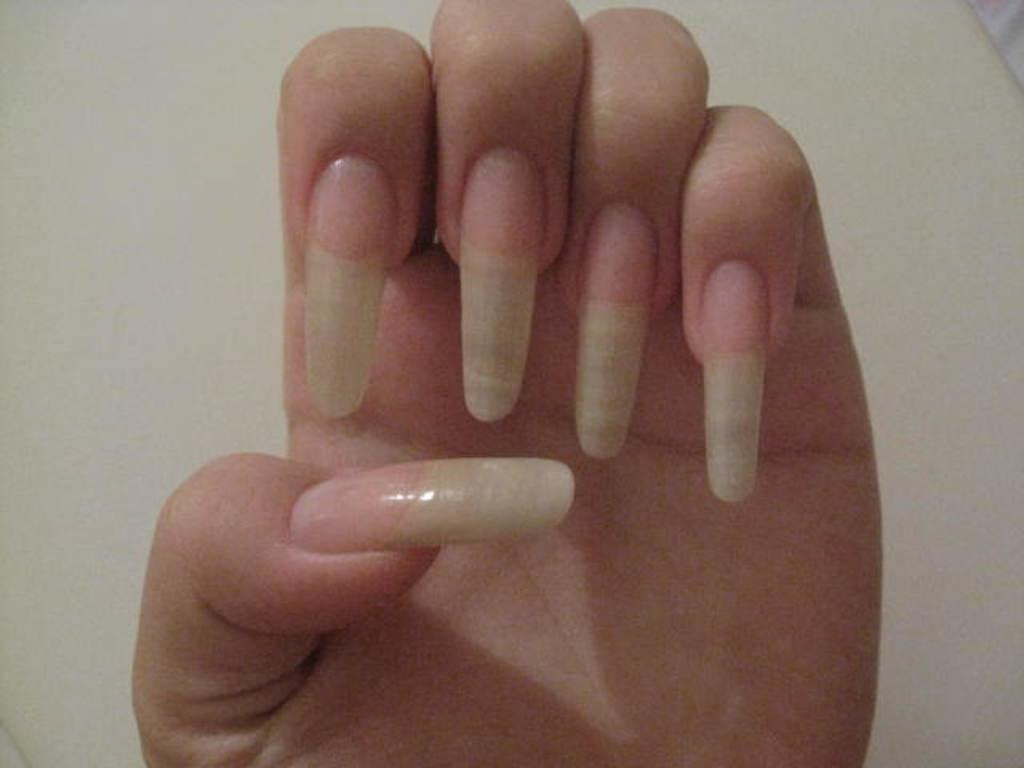What is the main subject of the image? The main subject of the image is a person's hand. What can be observed about the hand in the image? The hand has nails. What is the color of the background in the image? The background in the image is white. How many chairs are visible in the image? There are no chairs present in the image; it only features a person's hand. 